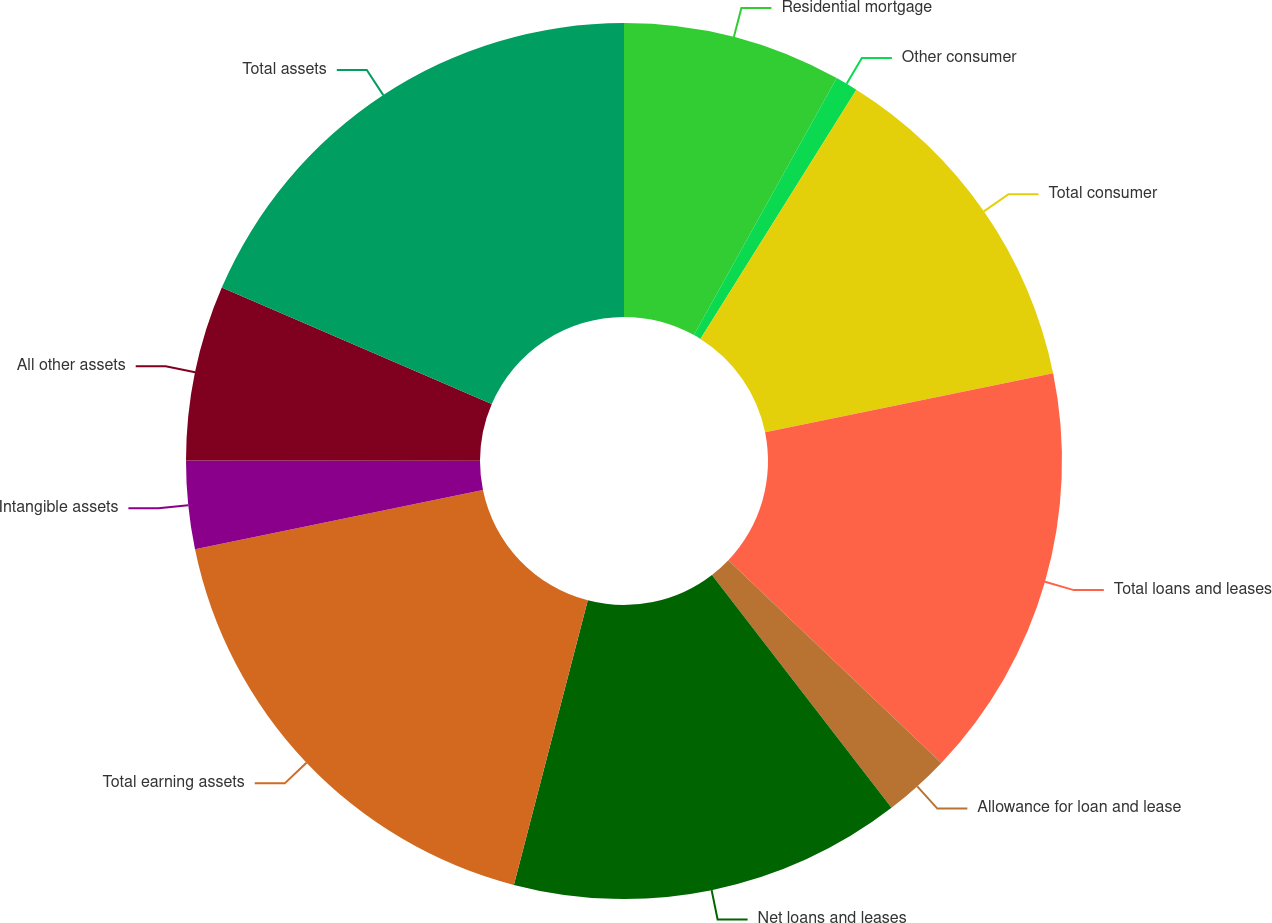Convert chart to OTSL. <chart><loc_0><loc_0><loc_500><loc_500><pie_chart><fcel>Residential mortgage<fcel>Other consumer<fcel>Total consumer<fcel>Total loans and leases<fcel>Allowance for loan and lease<fcel>Net loans and leases<fcel>Total earning assets<fcel>Intangible assets<fcel>All other assets<fcel>Total assets<nl><fcel>8.07%<fcel>0.83%<fcel>12.89%<fcel>15.31%<fcel>2.44%<fcel>14.5%<fcel>17.72%<fcel>3.25%<fcel>6.46%<fcel>18.52%<nl></chart> 